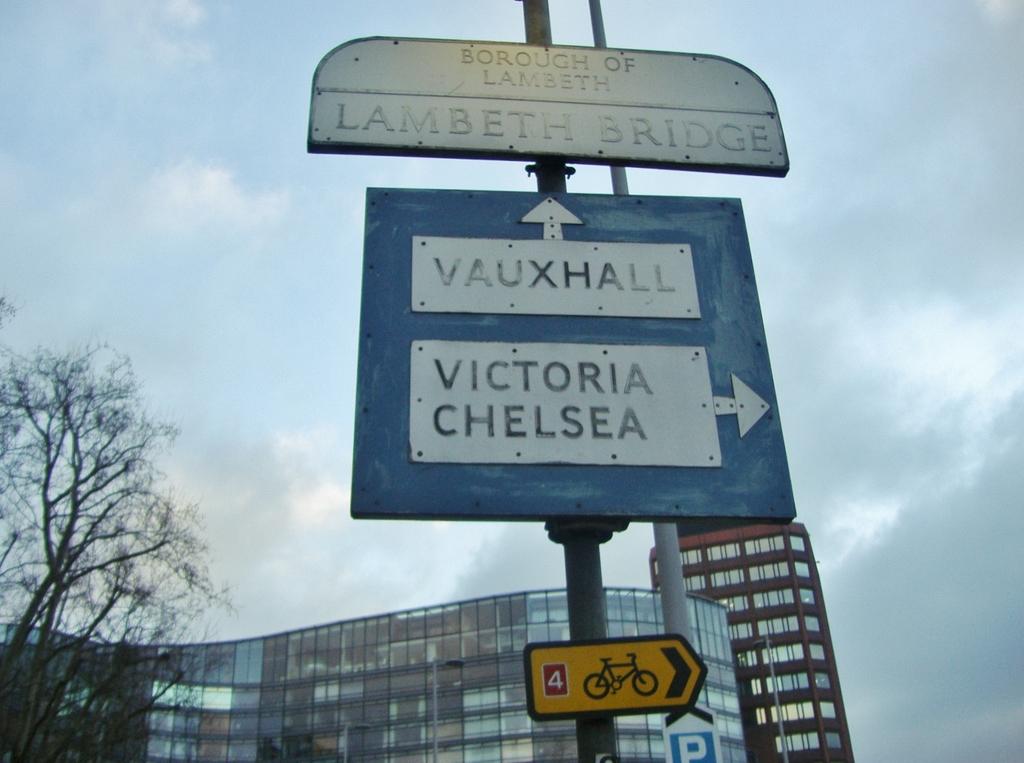Where would you be heading to if you traveled to the right?
Your answer should be very brief. Victoria chelsea. 